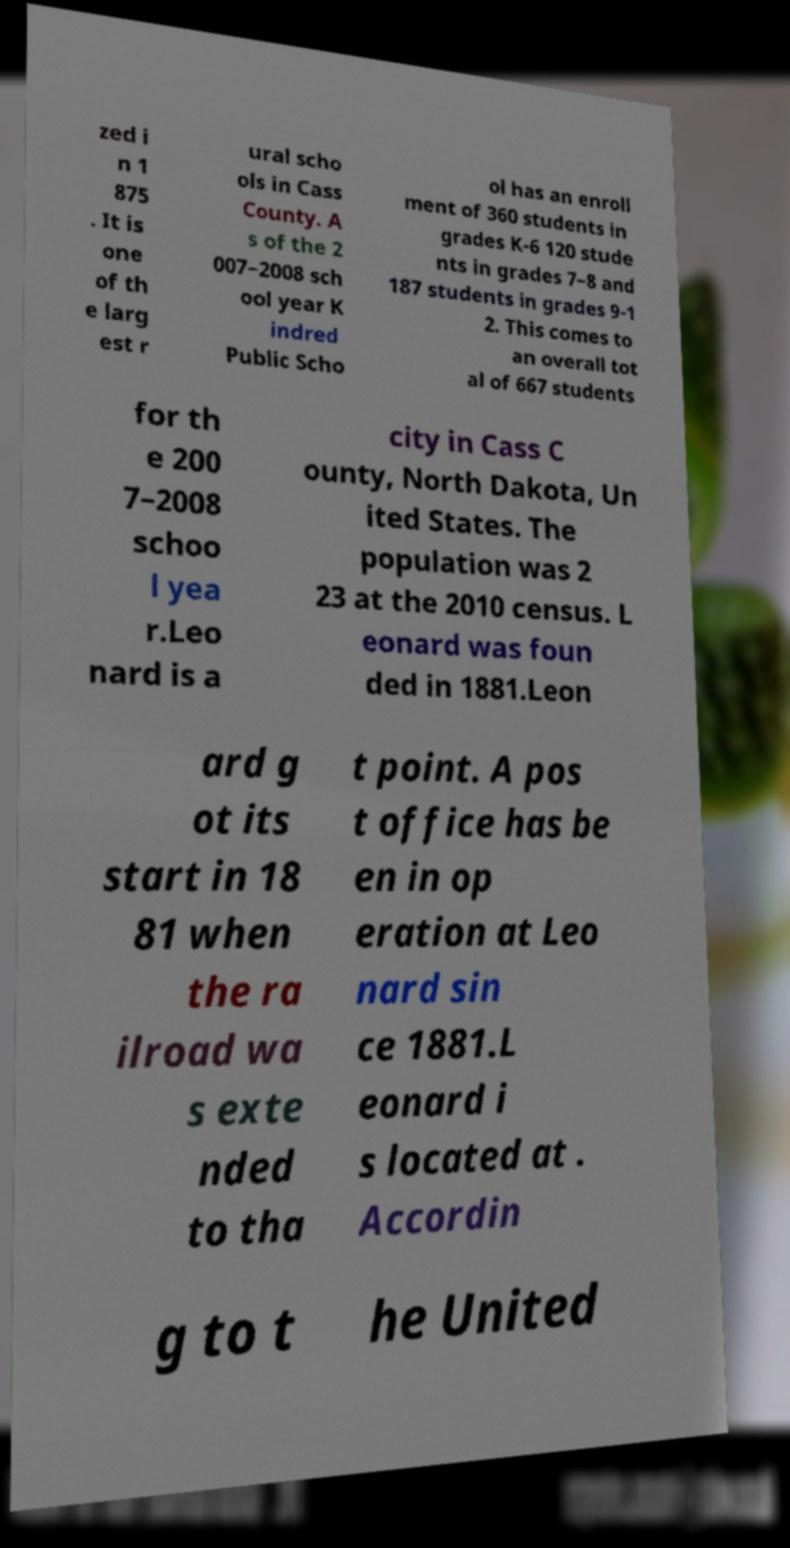For documentation purposes, I need the text within this image transcribed. Could you provide that? zed i n 1 875 . It is one of th e larg est r ural scho ols in Cass County. A s of the 2 007–2008 sch ool year K indred Public Scho ol has an enroll ment of 360 students in grades K-6 120 stude nts in grades 7–8 and 187 students in grades 9-1 2. This comes to an overall tot al of 667 students for th e 200 7–2008 schoo l yea r.Leo nard is a city in Cass C ounty, North Dakota, Un ited States. The population was 2 23 at the 2010 census. L eonard was foun ded in 1881.Leon ard g ot its start in 18 81 when the ra ilroad wa s exte nded to tha t point. A pos t office has be en in op eration at Leo nard sin ce 1881.L eonard i s located at . Accordin g to t he United 